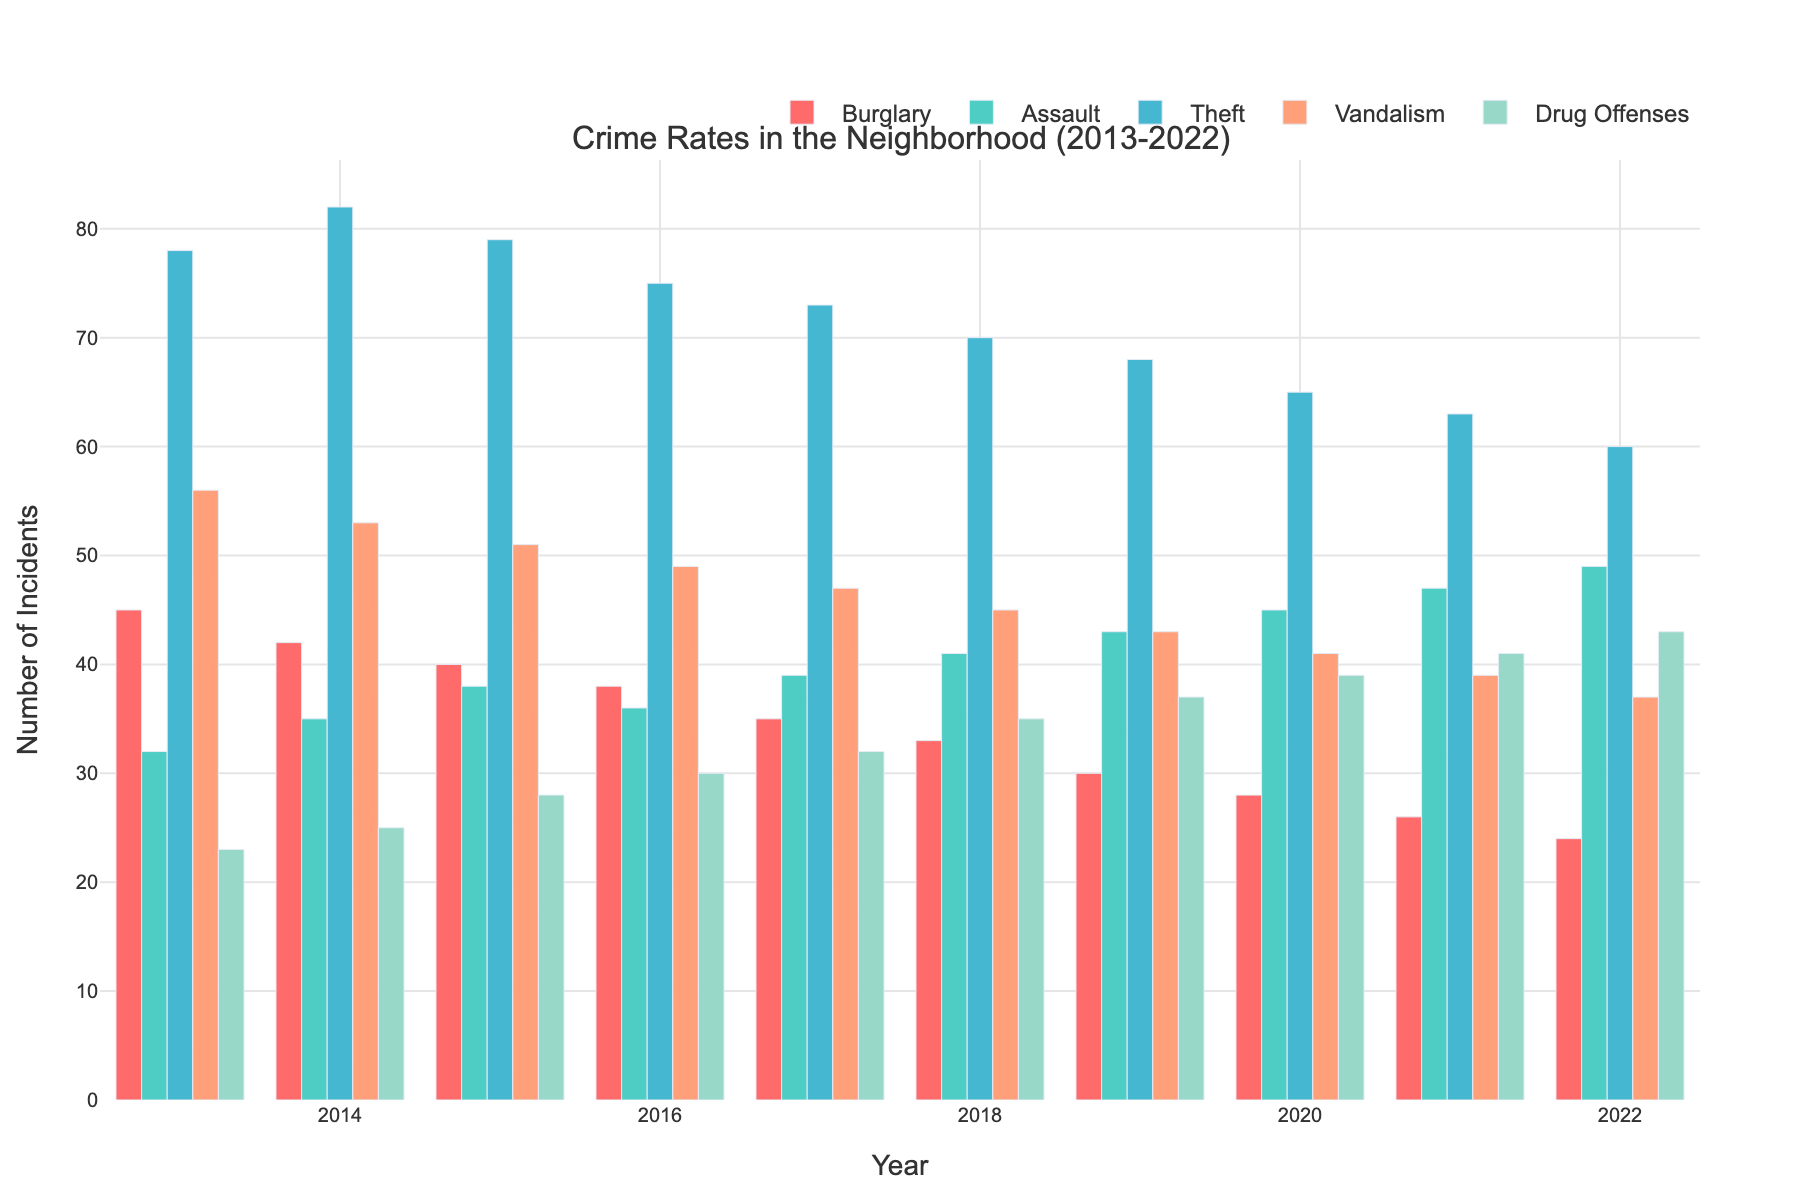Which type of crime had the highest number of incidents in 2022? Look at the bar height for each crime type in the year 2022; the tallest bar indicates the highest number of incidents.
Answer: Drug Offenses How does the number of burglary incidents in 2013 compare to 2022? Check the height of the burglary bars for the years 2013 and 2022. Compare which is taller and by how much.
Answer: Higher in 2013 What is the trend in vandalism incidents over the decade? Observe the height of the vandalism bars from 2013 to 2022 and note the changes.
Answer: Decreasing Which year had the highest number of assault incidents? Identify the tallest bar among all years in the assault category.
Answer: 2022 How many total theft incidents occurred in 2020? Locate the theft bar for the year 2020 and read off the value.
Answer: 65 What is the difference in drug offenses between 2013 and 2022? Subtract the number of drug offenses in 2013 from the number in 2022.
Answer: 20 Compare the number of vandalism incidents in 2015 to 2018. Compare the heights of the vandalism bars for 2015 and 2018 and note the difference.
Answer: Higher in 2015 What is the overall trend of burglary incidents from 2013 to 2022? Observe the burglary bars from 2013 to 2022 to identify if they generally increase, decrease, or remain stable.
Answer: Decreasing Is 2021 a peak year for assault incidents? Compare the assault bar height in 2021 to other years to see if it is the highest.
Answer: No What is the average number of theft incidents over the decade? Sum the number of theft incidents from 2013 to 2022 and divide by the number of years (10).
Answer: 70.3 